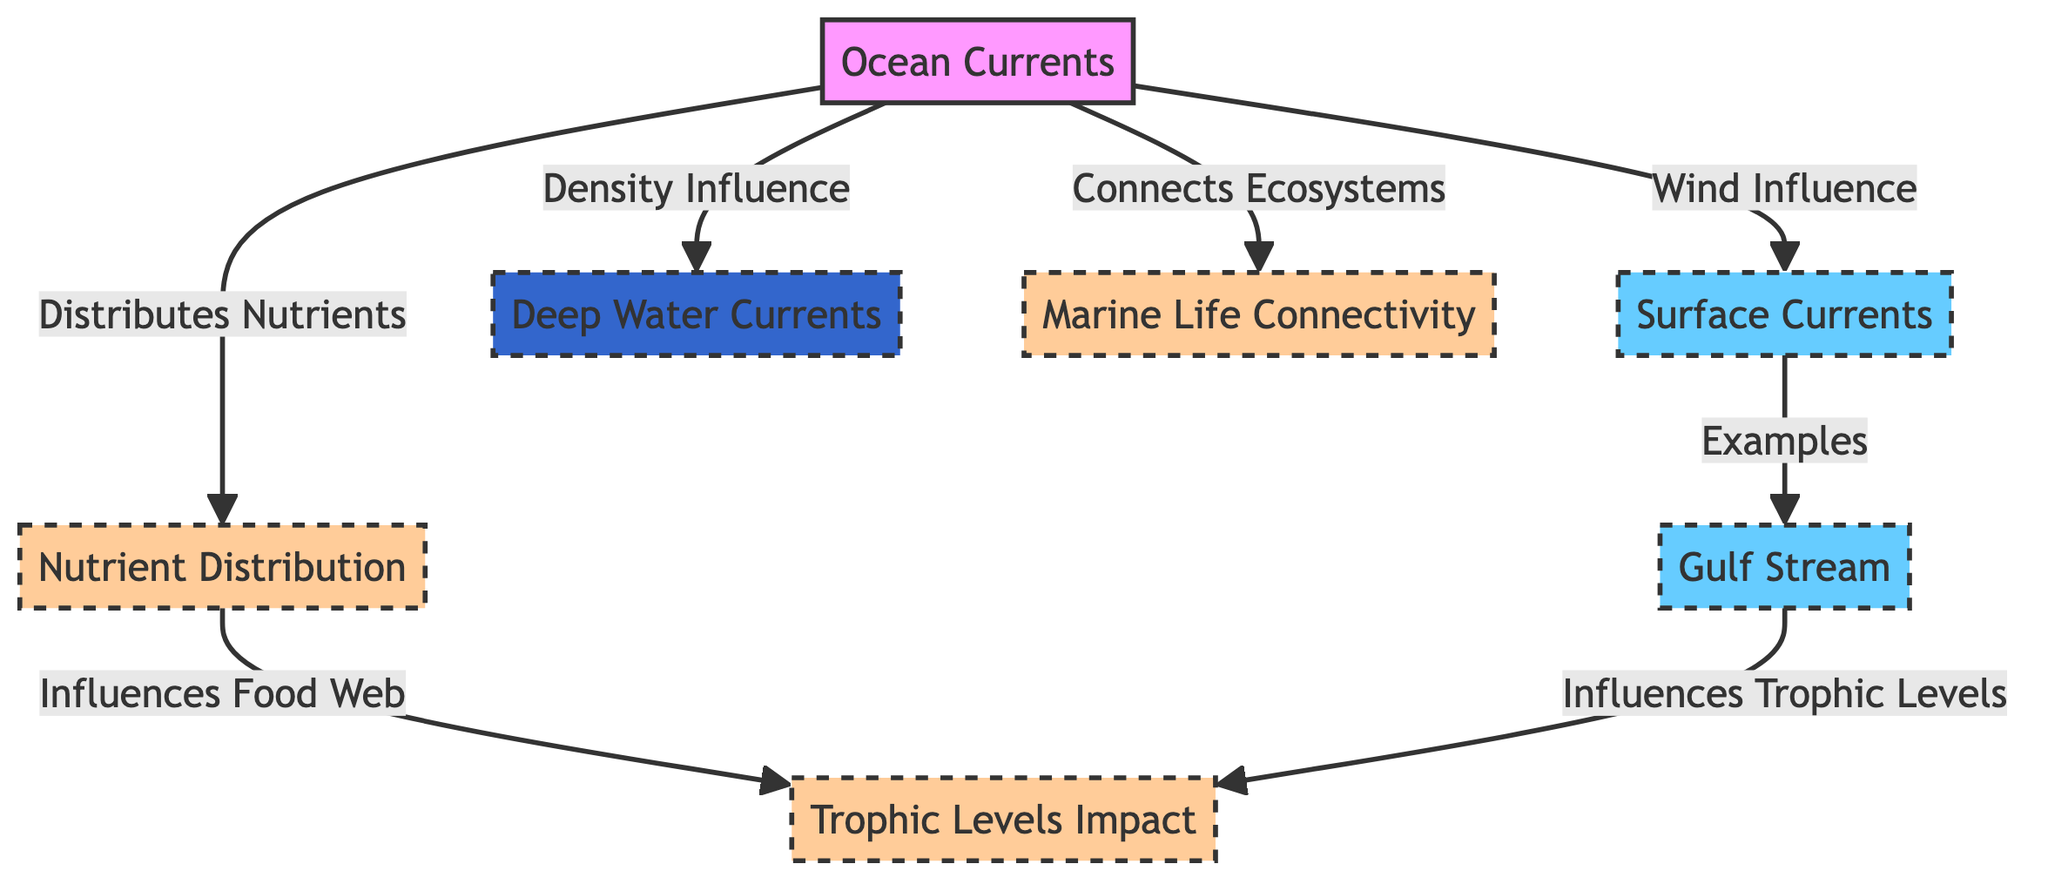What are the two types of currents depicted in the diagram? The diagram categorizes ocean currents into two types: Surface Currents and Deep Water Currents. These categories represent the layering of ocean currents based on their depth and influencing factors.
Answer: Surface Currents, Deep Water Currents Which current is an example of a surface current? Among the choices displayed in the diagram, the Gulf Stream is labeled as a specific example of a surface current, indicating its classification under the category of Surface Currents.
Answer: Gulf Stream How do surface currents influence marine life? The diagram illustrates that ocean currents connect ecosystems and distribute nutrients, both of which directly impact marine life. These flows create interdependencies among various marine organisms, demonstrating how currents support different life forms in the ocean.
Answer: Connects Ecosystems, Distributes Nutrients What influences deep water currents? According to the diagram, deep water currents are influenced by density, which refers to variations in water temperature and salinity that create differences in water density, ultimately driving these deeper currents.
Answer: Density Influence How many impacts of ocean currents on marine life are identified in the diagram? The diagram lists three specific impacts of ocean currents on marine life, highlighting how these currents contribute to connectivity, nutrient distribution, and trophic levels within the marine ecosystem.
Answer: Three Which current specifically influences trophic levels according to the diagram? The diagram indicates that the Gulf Stream influences trophic levels of marine life, suggesting a direct connection between this current and the complex food webs present in the ocean.
Answer: Gulf Stream What is the primary factor influencing surface currents? The primary factor listed in the diagram for influencing surface currents is wind, which underscores the critical role of atmospheric conditions on the movement of ocean surface waters.
Answer: Wind Influence How do nutrient distributions affect the food web according to the diagram? The diagram shows that nutrient distribution influences the food web, indicating that the availability and dispersion of nutrients is a fundamental factor for sustaining various trophic levels, which makes up the food web in the marine ecosystem.
Answer: Influences Food Web 